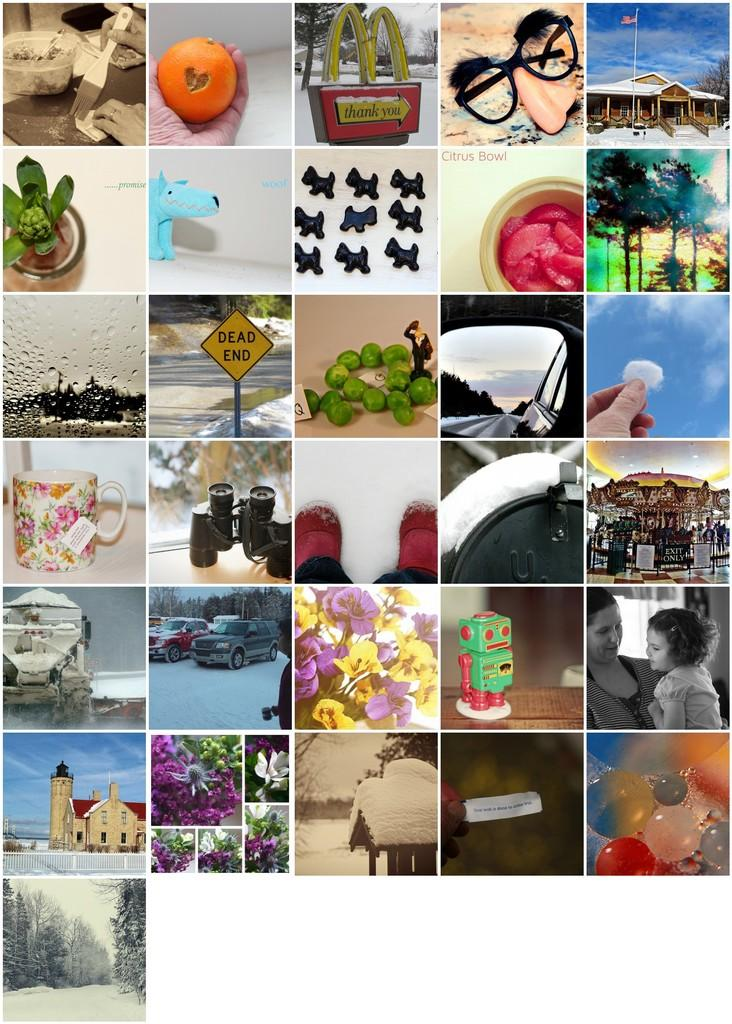What type of artwork is depicted in the image? The image is a collage of multiple images. How many goldfish can be seen swimming in the wilderness in the image? There are no goldfish or wilderness depicted in the image, as it is a collage of multiple images. 